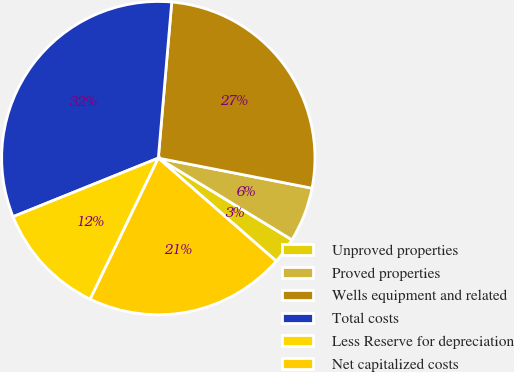Convert chart. <chart><loc_0><loc_0><loc_500><loc_500><pie_chart><fcel>Unproved properties<fcel>Proved properties<fcel>Wells equipment and related<fcel>Total costs<fcel>Less Reserve for depreciation<fcel>Net capitalized costs<nl><fcel>2.69%<fcel>5.66%<fcel>26.71%<fcel>32.47%<fcel>11.74%<fcel>20.73%<nl></chart> 